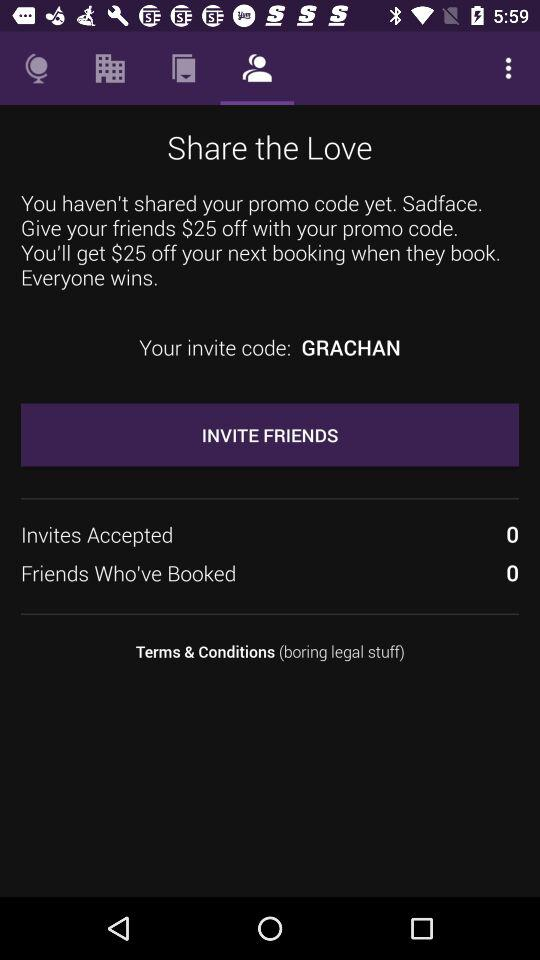How much of a discount do my friends get on this promo code? Your friend will get a discount of $25. 